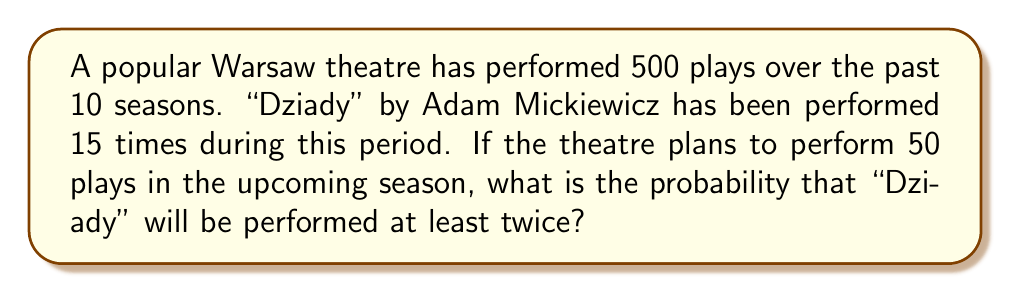Help me with this question. Let's approach this step-by-step using the binomial probability distribution:

1) First, we need to calculate the probability of "Dziady" being performed in any given play slot:
   $p = \frac{15}{500} = 0.03$

2) We want the probability of "Dziady" being performed at least twice in 50 plays. This is equivalent to 1 minus the probability of it being performed 0 or 1 times.

3) Let X be the number of times "Dziady" is performed. We need to find:
   $P(X \geq 2) = 1 - P(X = 0) - P(X = 1)$

4) We can use the binomial probability formula:
   $P(X = k) = \binom{n}{k} p^k (1-p)^{n-k}$
   where n = 50, p = 0.03

5) Calculating $P(X = 0)$:
   $P(X = 0) = \binom{50}{0} (0.03)^0 (0.97)^{50} = 0.2180$

6) Calculating $P(X = 1)$:
   $P(X = 1) = \binom{50}{1} (0.03)^1 (0.97)^{49} = 0.3355$

7) Therefore:
   $P(X \geq 2) = 1 - P(X = 0) - P(X = 1)$
                $= 1 - 0.2180 - 0.3355$
                $= 0.4465$

Thus, the probability of "Dziady" being performed at least twice in the upcoming season is approximately 0.4465 or 44.65%.
Answer: 0.4465 